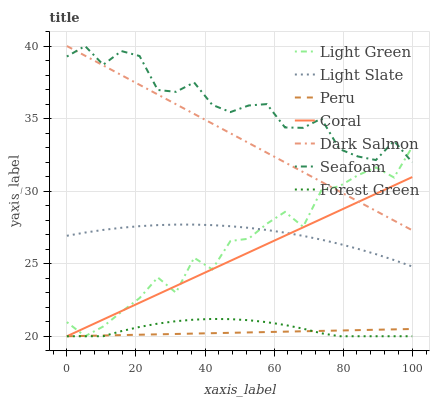Does Peru have the minimum area under the curve?
Answer yes or no. Yes. Does Seafoam have the maximum area under the curve?
Answer yes or no. Yes. Does Light Slate have the minimum area under the curve?
Answer yes or no. No. Does Light Slate have the maximum area under the curve?
Answer yes or no. No. Is Peru the smoothest?
Answer yes or no. Yes. Is Light Green the roughest?
Answer yes or no. Yes. Is Light Slate the smoothest?
Answer yes or no. No. Is Light Slate the roughest?
Answer yes or no. No. Does Light Green have the lowest value?
Answer yes or no. Yes. Does Light Slate have the lowest value?
Answer yes or no. No. Does Dark Salmon have the highest value?
Answer yes or no. Yes. Does Light Slate have the highest value?
Answer yes or no. No. Is Forest Green less than Dark Salmon?
Answer yes or no. Yes. Is Seafoam greater than Peru?
Answer yes or no. Yes. Does Seafoam intersect Dark Salmon?
Answer yes or no. Yes. Is Seafoam less than Dark Salmon?
Answer yes or no. No. Is Seafoam greater than Dark Salmon?
Answer yes or no. No. Does Forest Green intersect Dark Salmon?
Answer yes or no. No. 